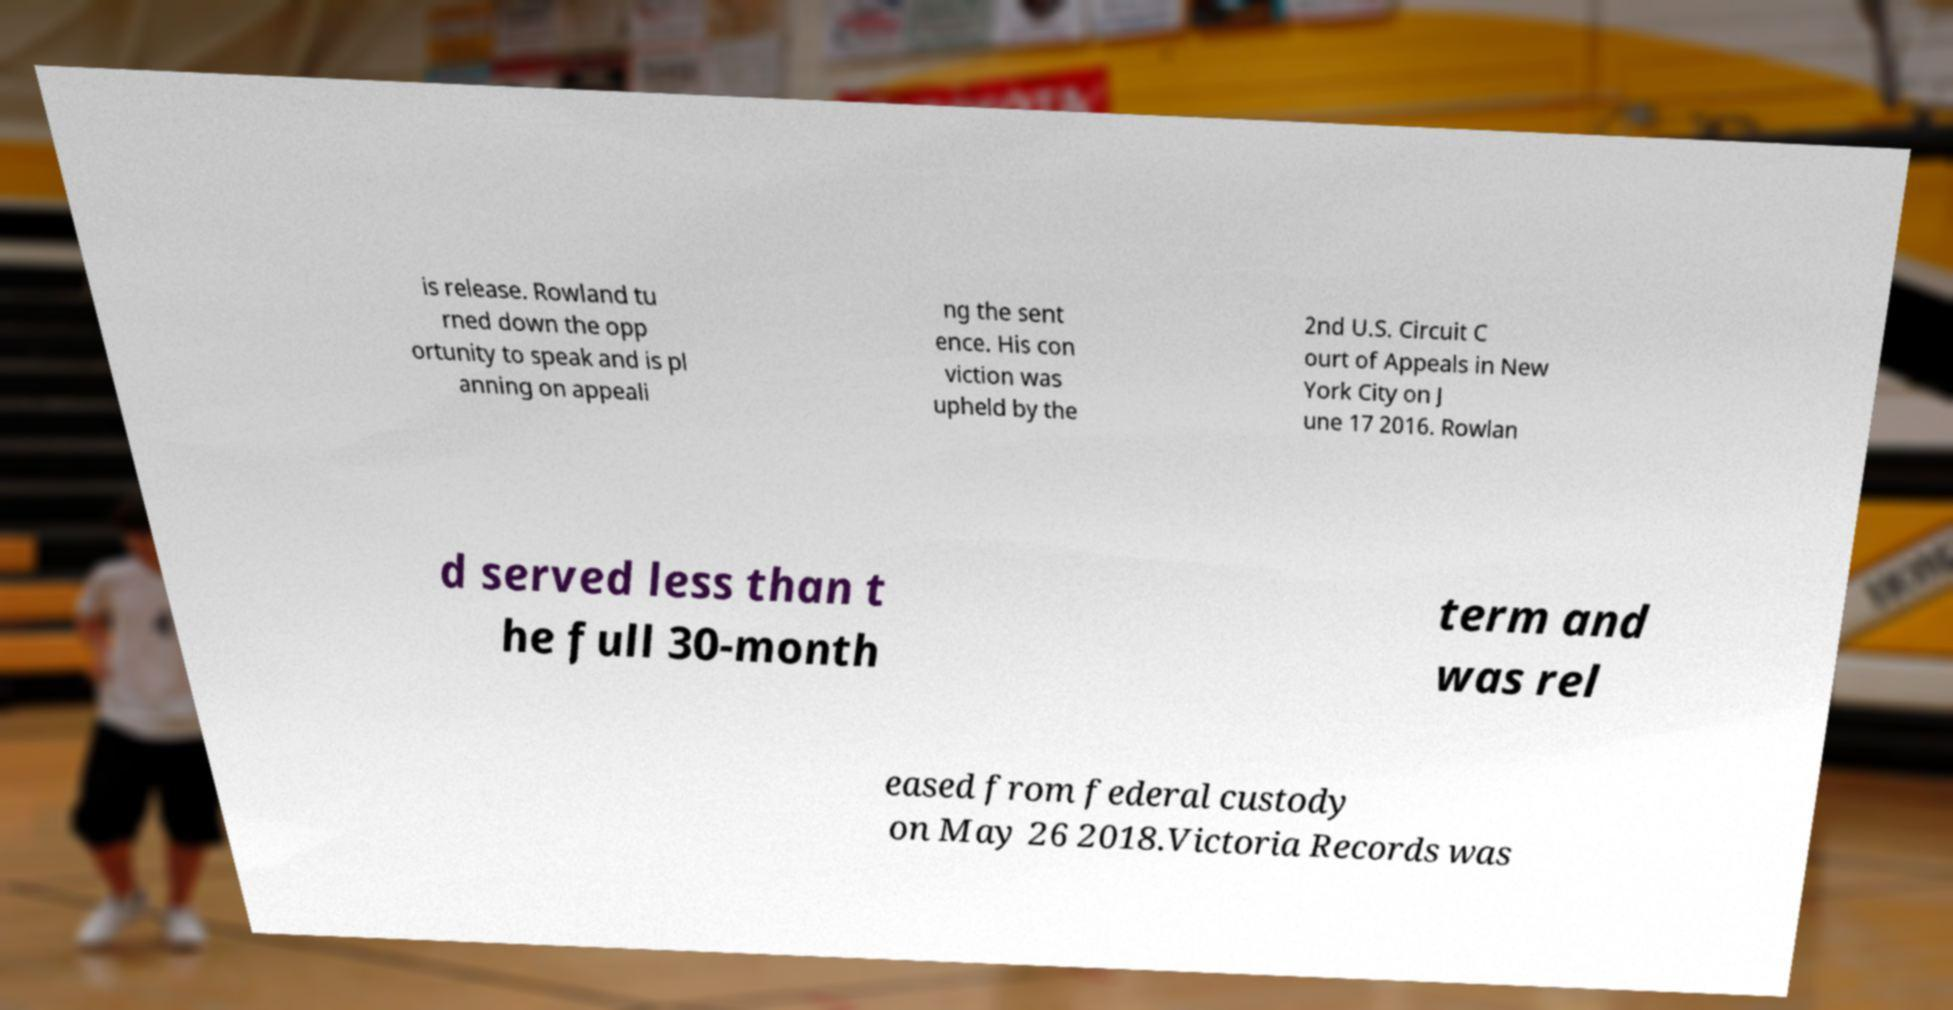Please identify and transcribe the text found in this image. is release. Rowland tu rned down the opp ortunity to speak and is pl anning on appeali ng the sent ence. His con viction was upheld by the 2nd U.S. Circuit C ourt of Appeals in New York City on J une 17 2016. Rowlan d served less than t he full 30-month term and was rel eased from federal custody on May 26 2018.Victoria Records was 